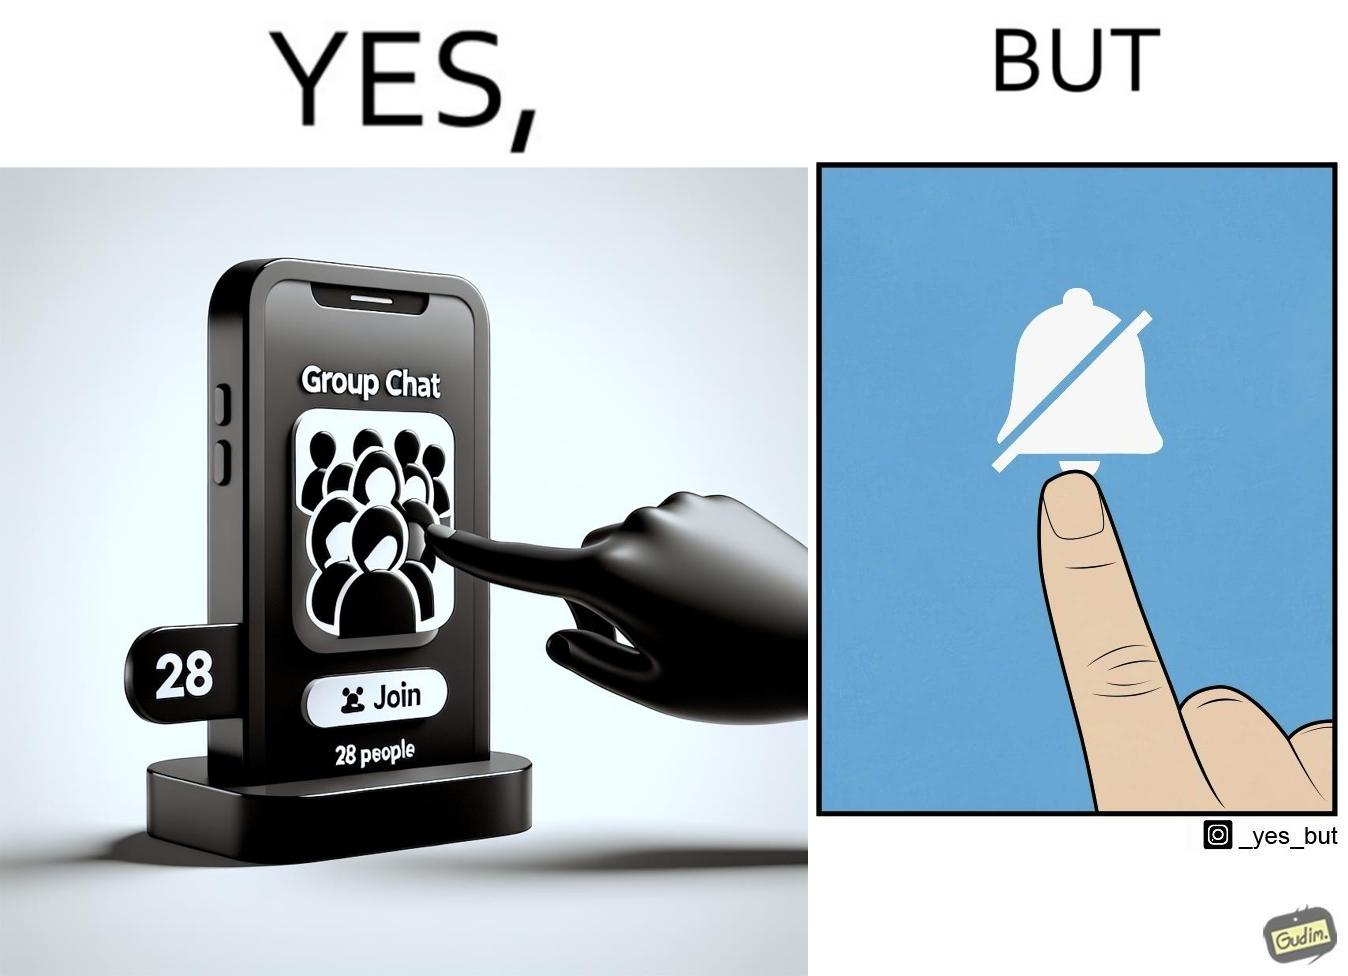Describe what you see in this image. This is ironic because the person joining the big social group, presumably interested in the happenings of that group, motivated to engage with these people, MUTEs the group as soon as they join it, indicating they are not interested in it and do not  want to be bothered by it.  These actions are contradictory from a social perspective, and illuminate a weird fact about present day online life. 